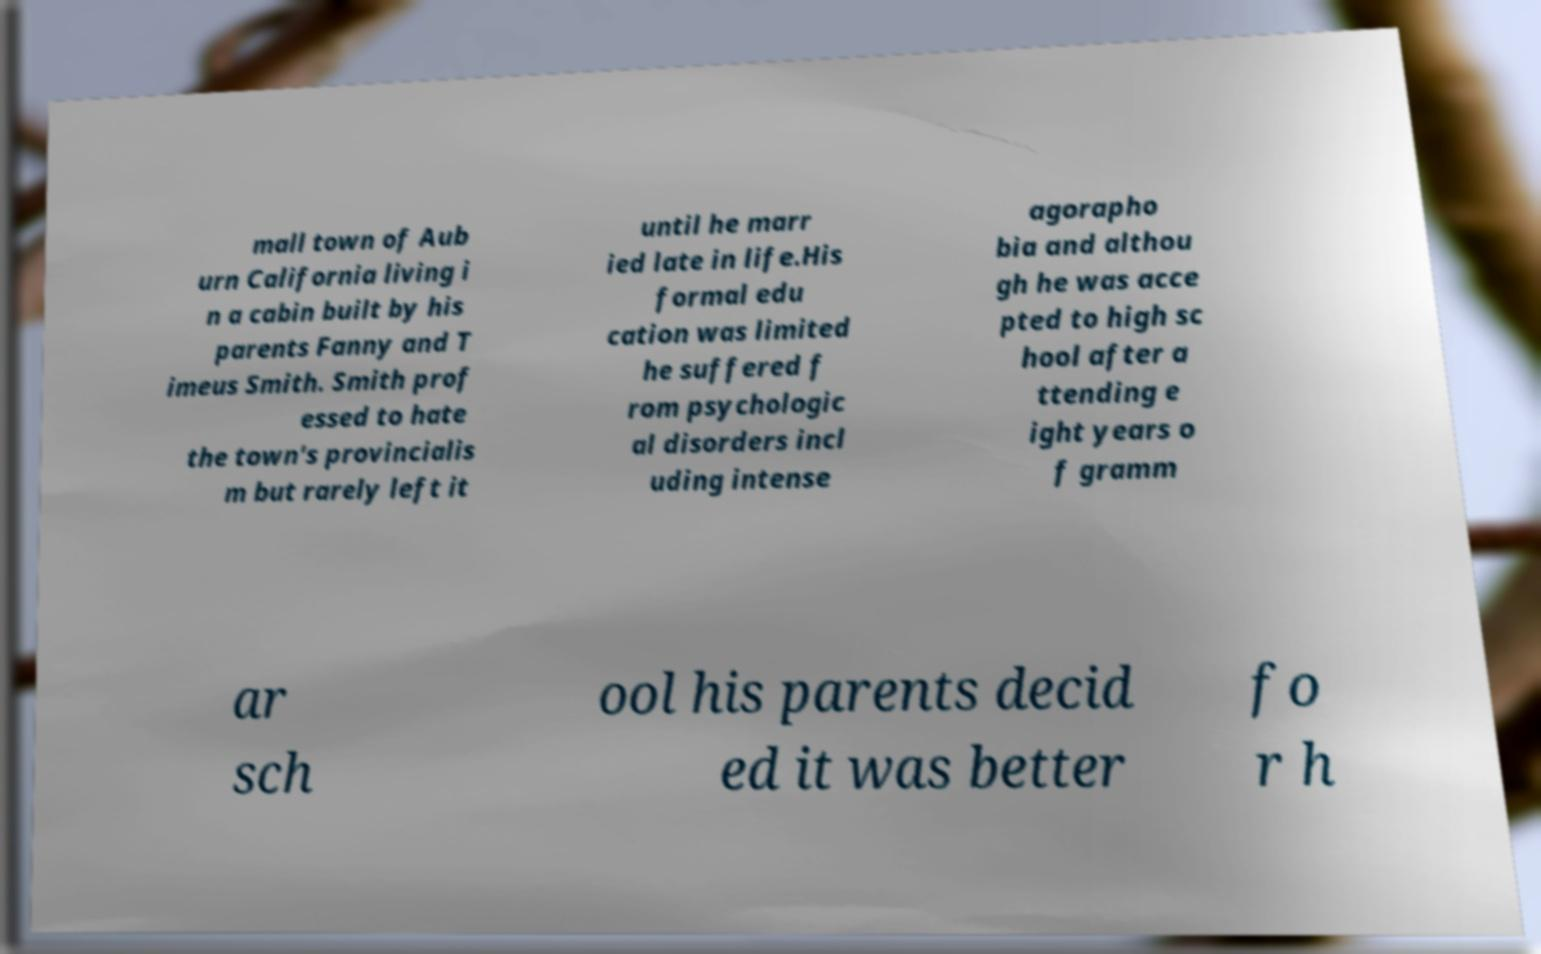Can you accurately transcribe the text from the provided image for me? mall town of Aub urn California living i n a cabin built by his parents Fanny and T imeus Smith. Smith prof essed to hate the town's provincialis m but rarely left it until he marr ied late in life.His formal edu cation was limited he suffered f rom psychologic al disorders incl uding intense agorapho bia and althou gh he was acce pted to high sc hool after a ttending e ight years o f gramm ar sch ool his parents decid ed it was better fo r h 